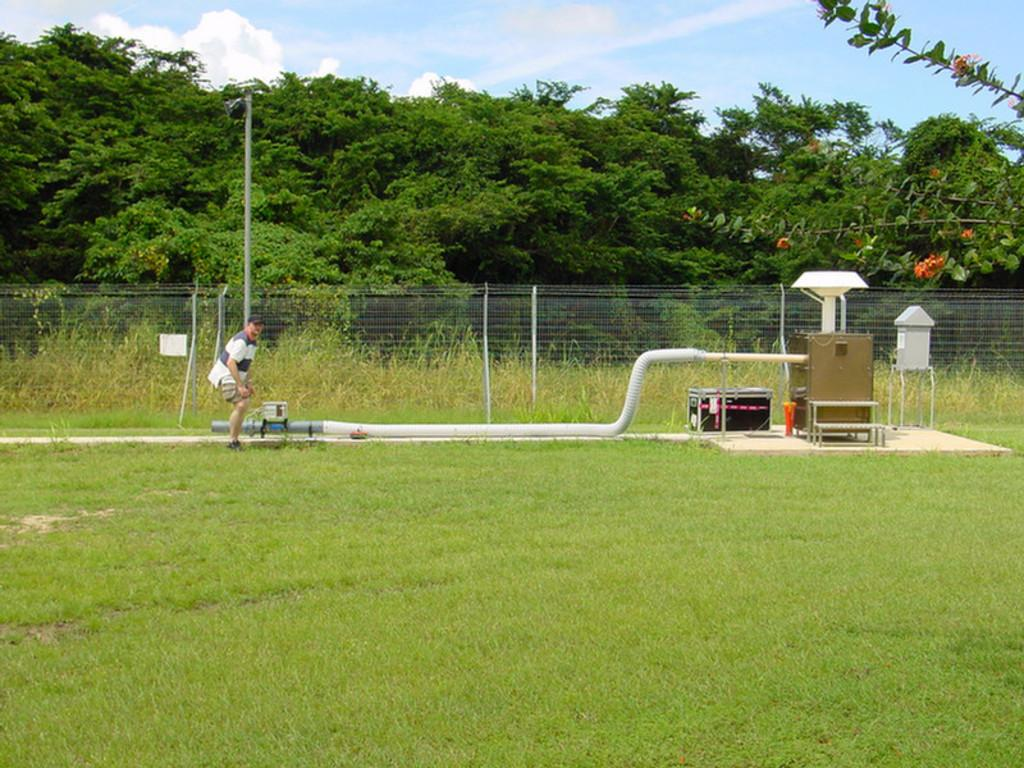Who or what is present in the image? There is a person in the image. Where is the person located? The person is on the grass. What other objects can be seen in the image? There are pipes, boxes, and fencing in the image. How is the fencing secured in the image? The fencing is connected to the ground. What can be seen beyond the fencing? There are trees visible on the other side of the fencing. What type of plough is being used to create a circle in the image? There is no plough or circle present in the image. How does the person stop the pipes from moving in the image? The person is not shown stopping the pipes from moving in the image; the pipes are stationary. 